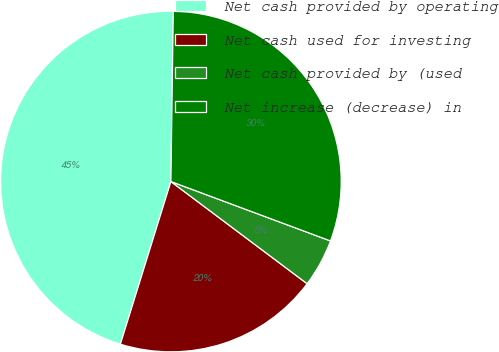Convert chart. <chart><loc_0><loc_0><loc_500><loc_500><pie_chart><fcel>Net cash provided by operating<fcel>Net cash used for investing<fcel>Net cash provided by (used<fcel>Net increase (decrease) in<nl><fcel>45.43%<fcel>19.55%<fcel>4.57%<fcel>30.45%<nl></chart> 